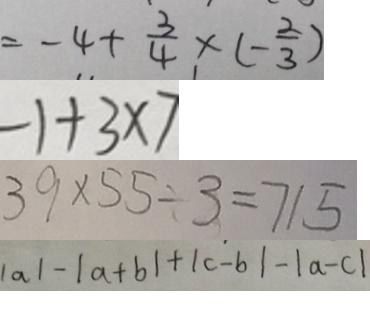Convert formula to latex. <formula><loc_0><loc_0><loc_500><loc_500>= - 4 + \frac { 3 } { 4 } \times ( - \frac { 2 } { 3 } ) 
 - 1 + 3 \times 7 
 3 9 \times 5 5 \div 3 = 7 1 5 
 \vert a \vert - \vert a + b \vert + \vert c - b \vert - \vert a - c \vert</formula> 